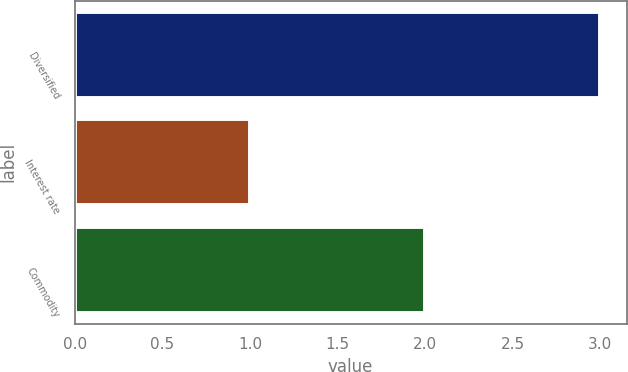Convert chart. <chart><loc_0><loc_0><loc_500><loc_500><bar_chart><fcel>Diversified<fcel>Interest rate<fcel>Commodity<nl><fcel>3<fcel>1<fcel>2<nl></chart> 